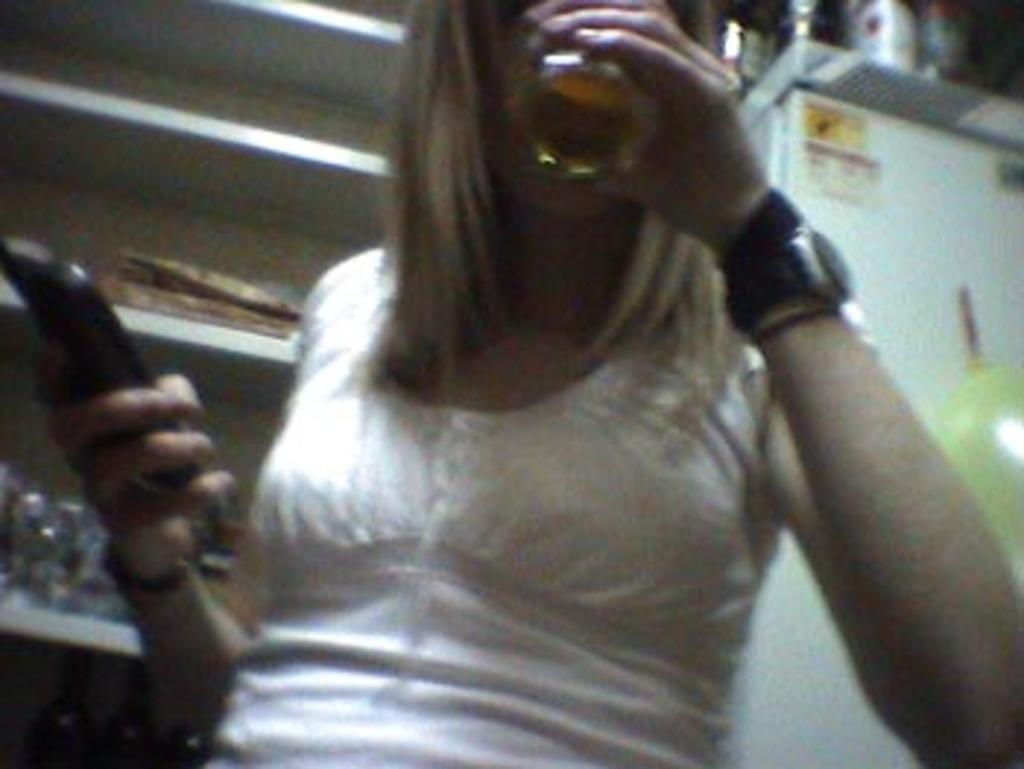Describe this image in one or two sentences. In this image there is a person truncated towards the top of the image, the person is holding an object, there are shelves truncated, there are objects on the shelves, there is an object truncated towards the right of the image, there are objects truncated towards the top of the image, there are objects truncated towards the bottom of the image. 